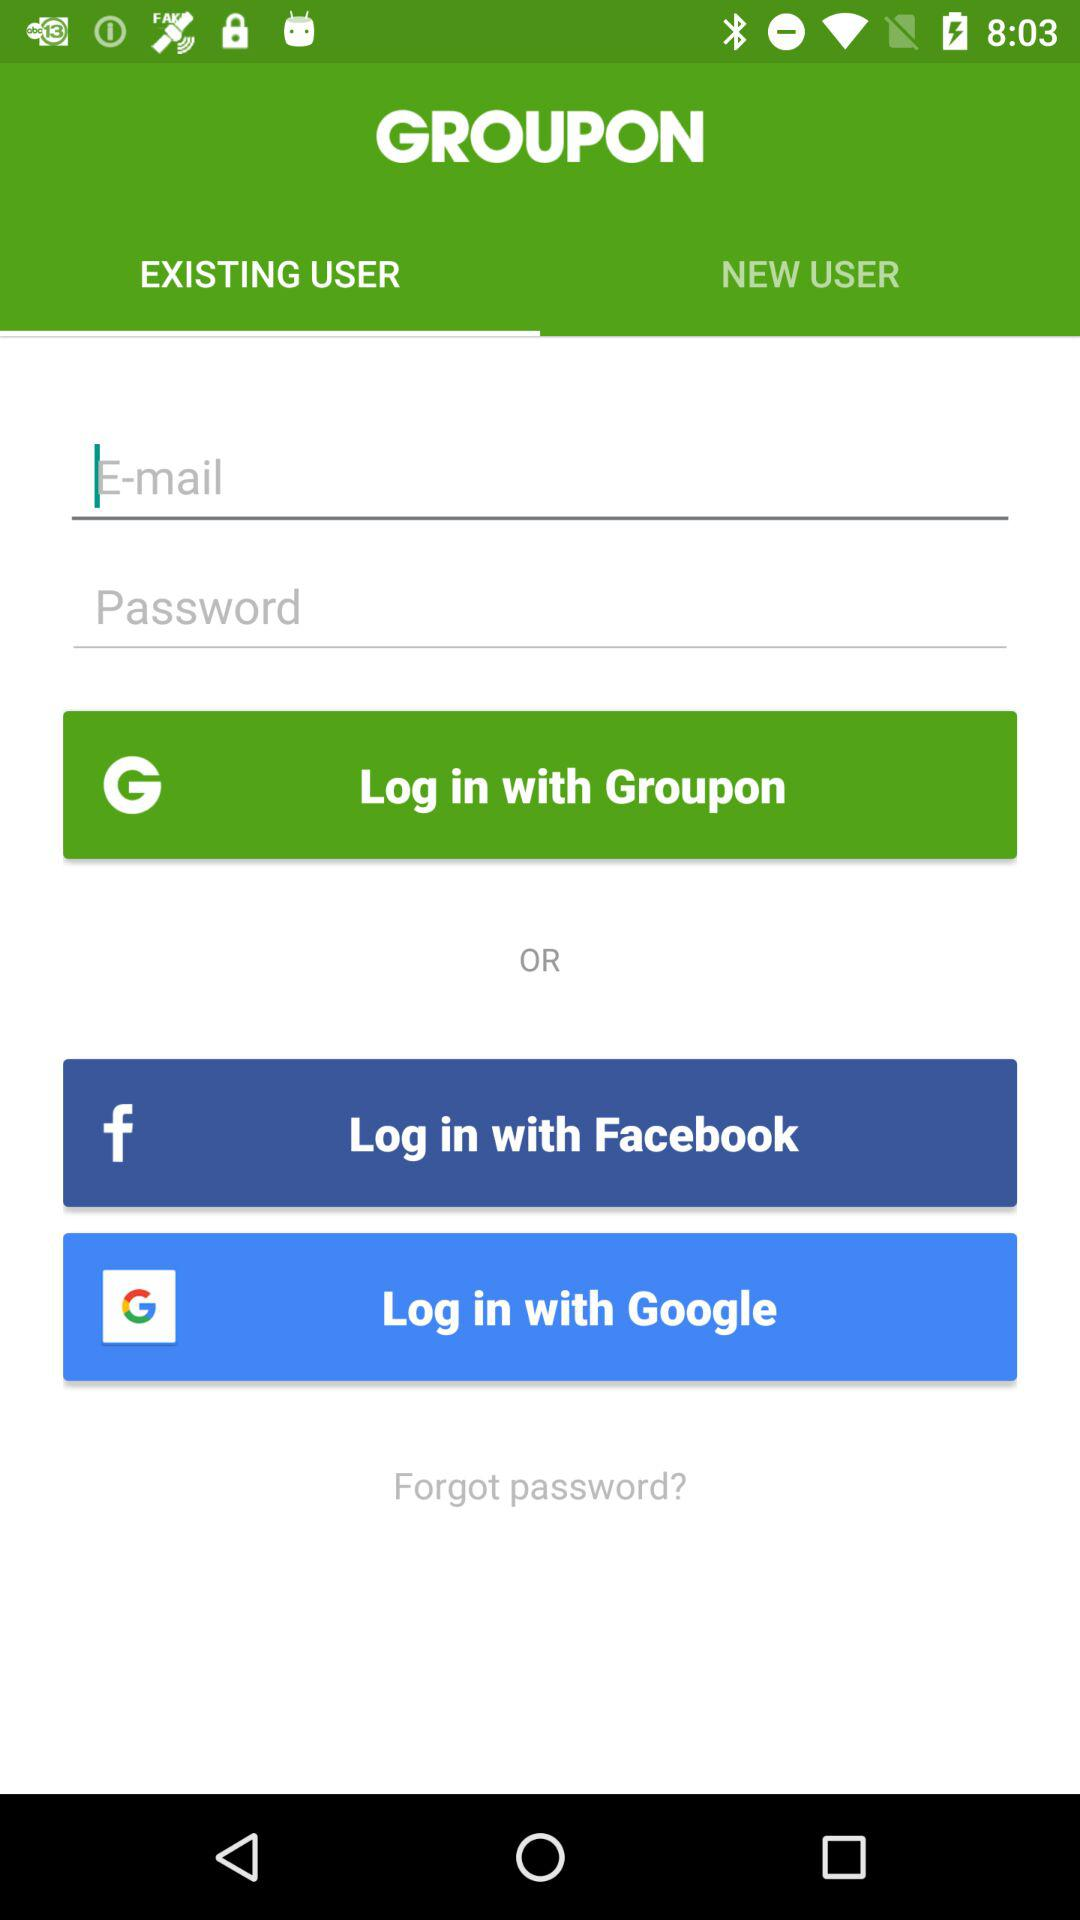Which tab is selected? The selected tab is "EXISTING USER". 